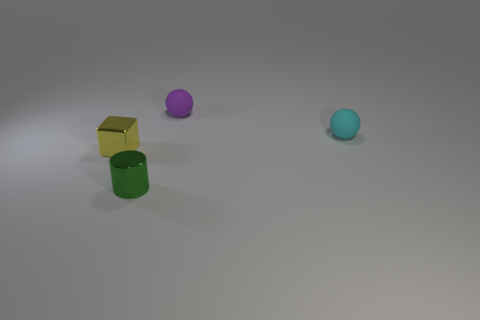Subtract all cylinders. How many objects are left? 3 Add 2 purple balls. How many objects exist? 6 Subtract all small cylinders. Subtract all big metal objects. How many objects are left? 3 Add 3 cyan rubber balls. How many cyan rubber balls are left? 4 Add 4 small yellow spheres. How many small yellow spheres exist? 4 Subtract 0 blue balls. How many objects are left? 4 